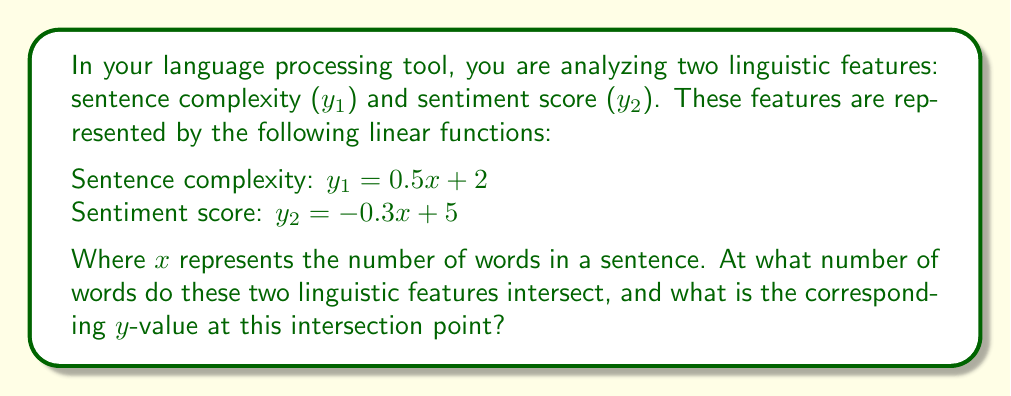Solve this math problem. To find the intersection point of these two linear functions, we need to solve the system of equations:

$$\begin{cases}
y_1 = 0.5x + 2 \\
y_2 = -0.3x + 5
\end{cases}$$

At the intersection point, $y_1 = y_2$, so we can set the equations equal to each other:

$$0.5x + 2 = -0.3x + 5$$

Now, let's solve for x:

1) First, add 0.3x to both sides:
   $$0.8x + 2 = 5$$

2) Subtract 2 from both sides:
   $$0.8x = 3$$

3) Divide both sides by 0.8:
   $$x = \frac{3}{0.8} = 3.75$$

So, the x-coordinate of the intersection point is 3.75 words.

To find the y-coordinate, we can substitute this x-value into either of the original equations. Let's use the first equation:

$$y = 0.5(3.75) + 2 = 1.875 + 2 = 3.875$$

Therefore, the intersection point is (3.75, 3.875).
Answer: (3.75, 3.875) 